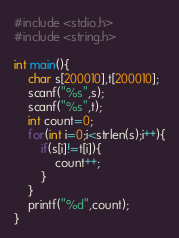Convert code to text. <code><loc_0><loc_0><loc_500><loc_500><_C_>#include <stdio.h>
#include <string.h>

int main(){
    char s[200010],t[200010];
    scanf("%s",s);
    scanf("%s",t);
    int count=0;
    for(int i=0;i<strlen(s);i++){
        if(s[i]!=t[i]){
            count++;
        }
    }
    printf("%d",count);
}</code> 